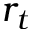Convert formula to latex. <formula><loc_0><loc_0><loc_500><loc_500>r _ { t }</formula> 